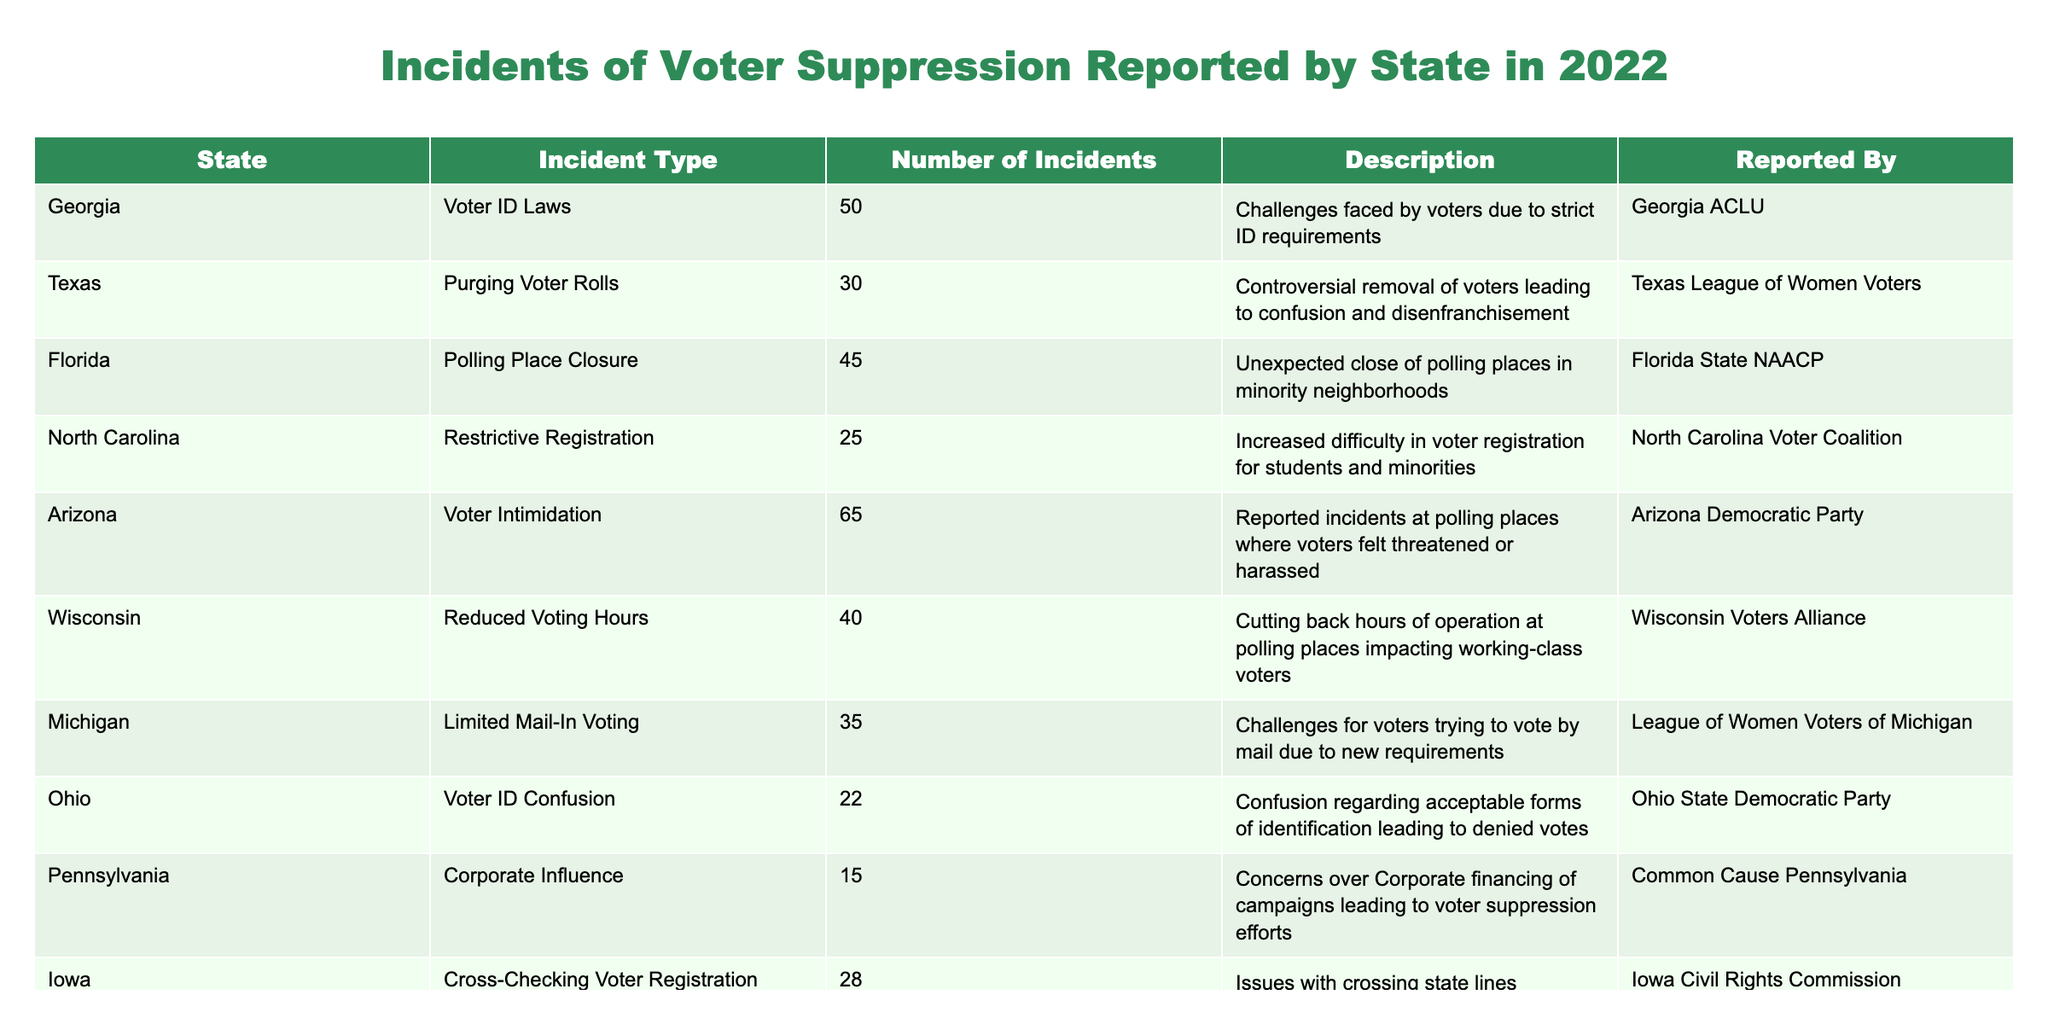What is the total number of voter suppression incidents reported in Georgia? According to the table, Georgia had 50 voter suppression incidents reported in 2022. This value can be found in the "Number of Incidents" column corresponding to Georgia in the table.
Answer: 50 Which state reported the highest number of voter intimidation incidents? Arizona reported the highest number of voter intimidation incidents with a total of 65 incidents, as indicated in the "Number of Incidents" column next to Arizona in the table.
Answer: 65 Is there any state that reported fewer than 20 incidents of voter suppression? Yes, Pennsylvania reported 15 incidents of voter suppression, which is fewer than 20. This is noted in the "Number of Incidents" column for Pennsylvania.
Answer: Yes What is the average number of incidents reported across all states? To calculate the average, first sum the number of incidents: 50 + 30 + 45 + 25 + 65 + 40 + 35 + 22 + 15 + 28 =  410 incidents. Then, divide by the number of states (10): 410 / 10 = 41. Therefore, the average number of incidents is 41.
Answer: 41 Which type of voter suppression incident was reported in the most states? To find this, we can count the unique types of incidents listed: Voter ID Laws, Purging Voter Rolls, Polling Place Closure, Restrictive Registration, Voter Intimidation, Reduced Voting Hours, Limited Mail-In Voting, Voter ID Confusion, Corporate Influence, and Cross-Checking Voter Registration. All ten types of incidents are reported in unique states, indicating that no single type dominates.
Answer: All types are reported in unique states 